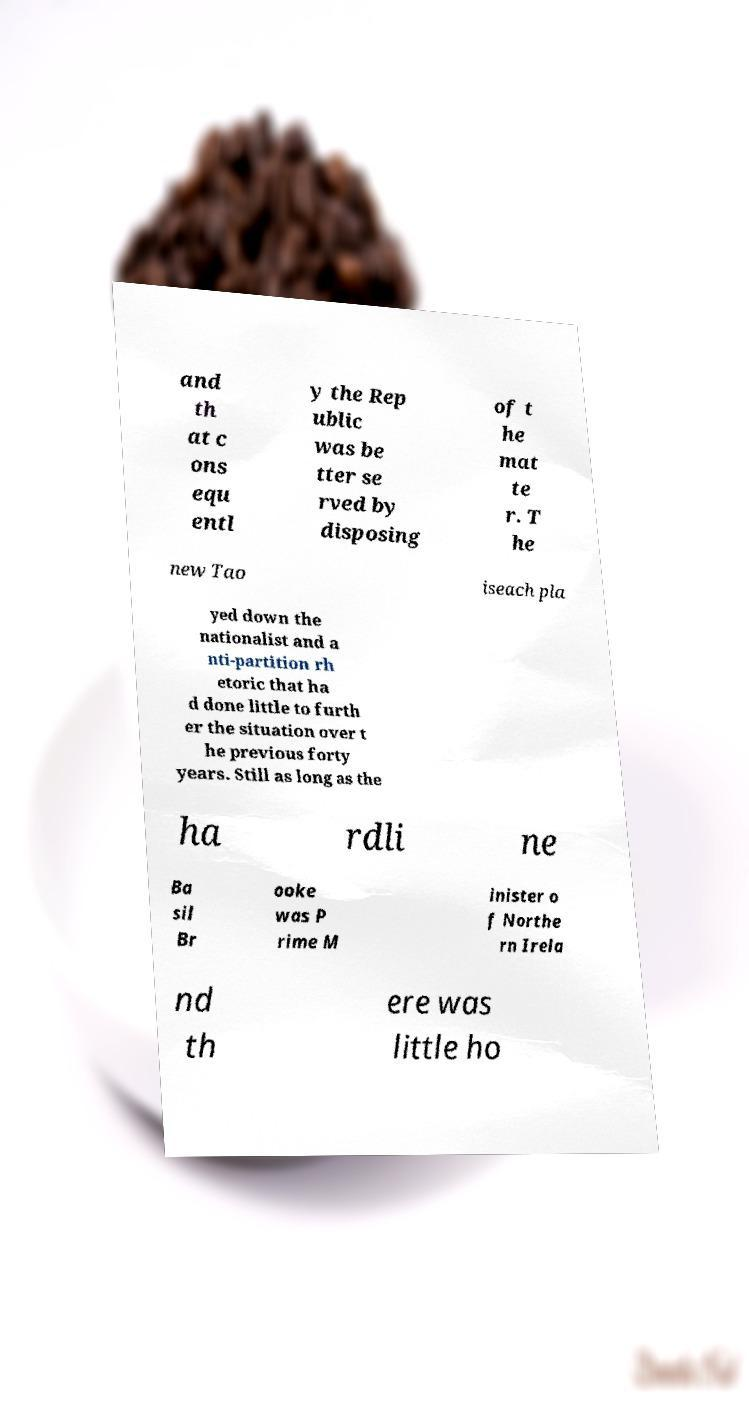Could you extract and type out the text from this image? and th at c ons equ entl y the Rep ublic was be tter se rved by disposing of t he mat te r. T he new Tao iseach pla yed down the nationalist and a nti-partition rh etoric that ha d done little to furth er the situation over t he previous forty years. Still as long as the ha rdli ne Ba sil Br ooke was P rime M inister o f Northe rn Irela nd th ere was little ho 